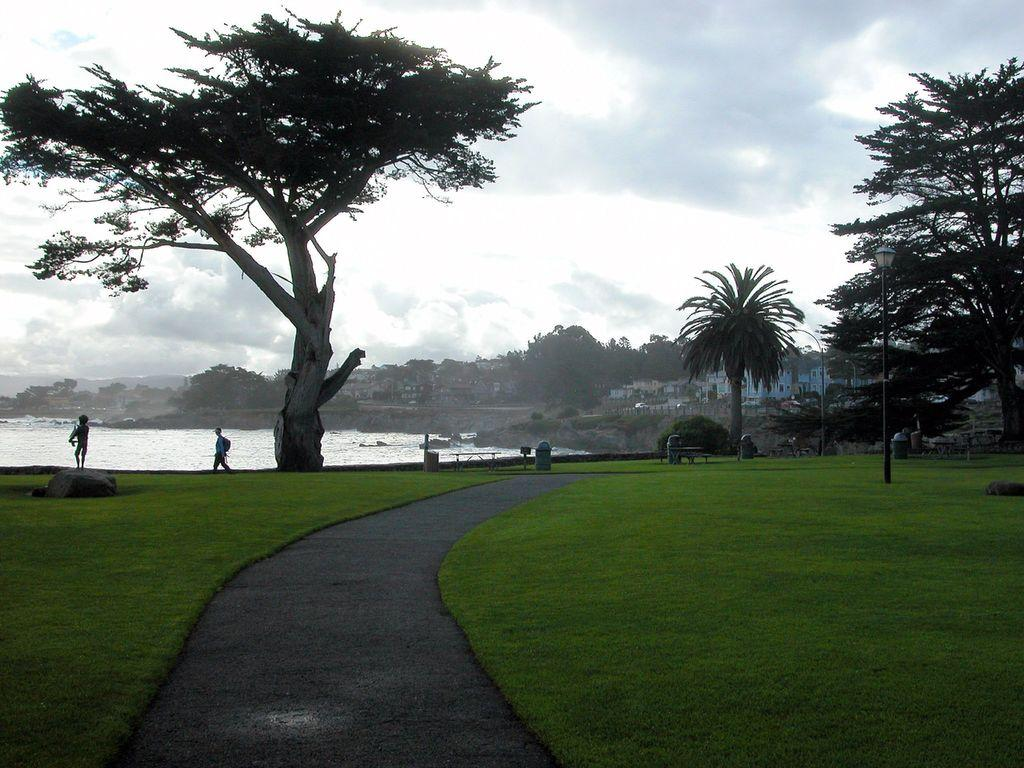What type of vegetation is present on the ground in the front of the image? There is grass on the ground in the front of the image. What can be seen in the background of the image? There are trees, buildings, and persons in the background of the image. What is visible in the image besides the grass and background elements? There is water visible in the image, as well as bins. How would you describe the weather based on the image? The sky is cloudy in the image, suggesting a potentially overcast or cloudy day. What type of game is being played by the persons in the image? There is no game being played by the persons in the image; they are simply visible in the background. Can you see a ring on any of the trees in the image? There is no ring visible on any of the trees in the image. 